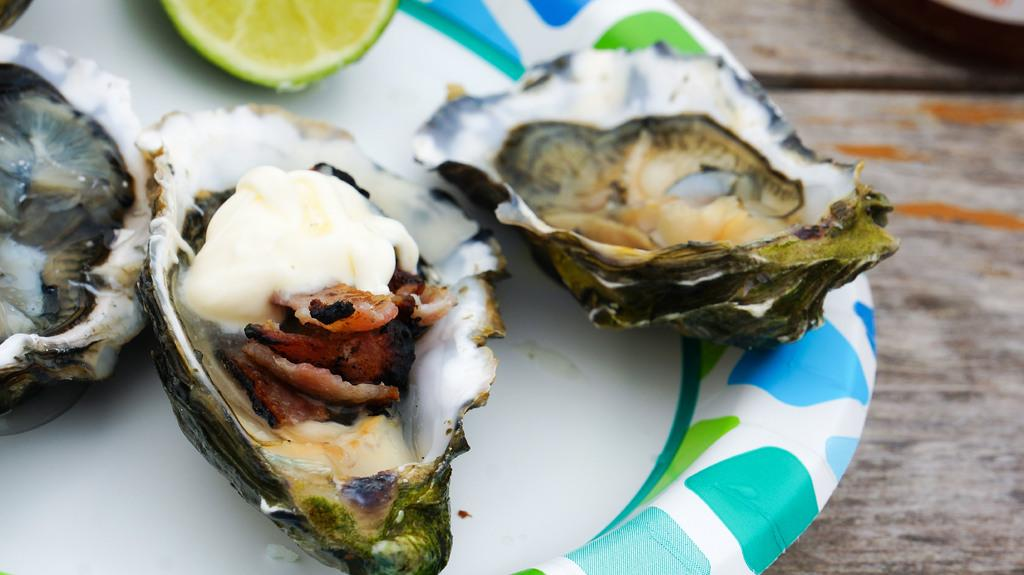What types of food items can be seen in the image? There are food items in the image, but their specific types are not mentioned. What is the citrus fruit present in the image? There is a slice of lemon in the image. Where are the food items and lemon located? The food items and lemon are on a plate. On what surface is the plate placed? The plate is placed on a table. What type of tax is being discussed in the image? There is no mention of tax in the image; it features food items and a slice of lemon on a plate. What color is the vest being worn by the person in the image? There is no person or vest present in the image. 